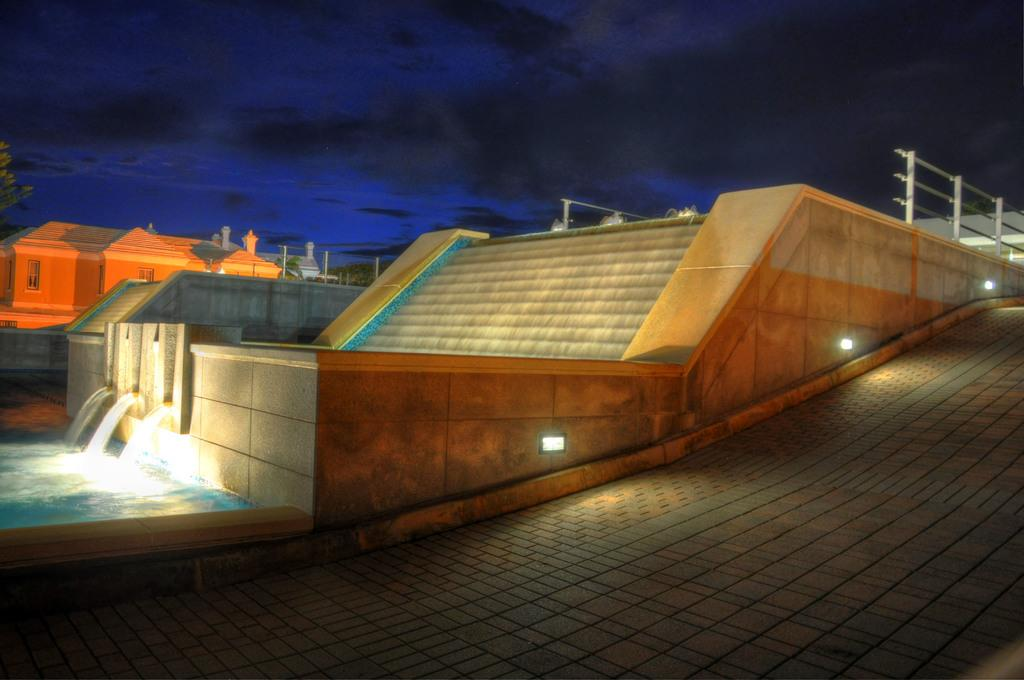What type of structures can be seen in the image? There are houses in the image. What other natural elements are present in the image? There are trees and water visible in the image. What architectural feature can be seen in the houses? There are windows in the image. Can you describe the outdoor environment in the image? There is a staircase, a fence, and the sky is visible in the background of the image. What is the weather like in the image? Clouds are present in the sky, indicating that it might be a partly cloudy day. Can you see a rabbit playing in the water in the image? There is no rabbit present in the image, and no indication of any playful activity in the water. 